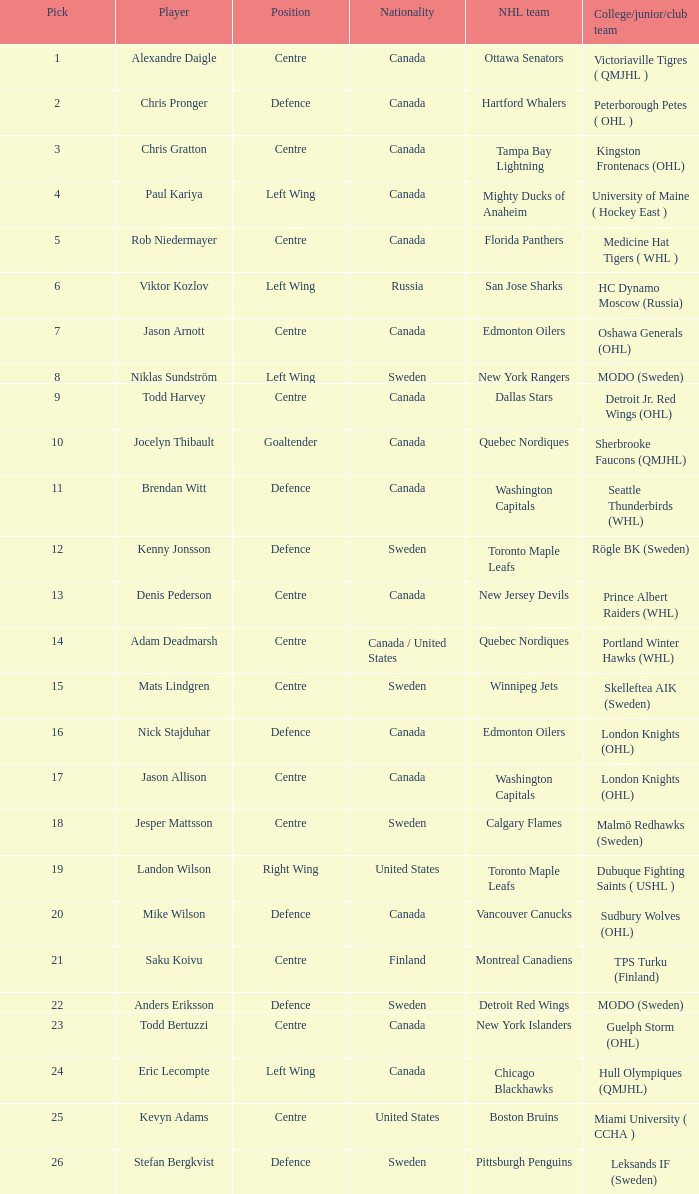Parse the table in full. {'header': ['Pick', 'Player', 'Position', 'Nationality', 'NHL team', 'College/junior/club team'], 'rows': [['1', 'Alexandre Daigle', 'Centre', 'Canada', 'Ottawa Senators', 'Victoriaville Tigres ( QMJHL )'], ['2', 'Chris Pronger', 'Defence', 'Canada', 'Hartford Whalers', 'Peterborough Petes ( OHL )'], ['3', 'Chris Gratton', 'Centre', 'Canada', 'Tampa Bay Lightning', 'Kingston Frontenacs (OHL)'], ['4', 'Paul Kariya', 'Left Wing', 'Canada', 'Mighty Ducks of Anaheim', 'University of Maine ( Hockey East )'], ['5', 'Rob Niedermayer', 'Centre', 'Canada', 'Florida Panthers', 'Medicine Hat Tigers ( WHL )'], ['6', 'Viktor Kozlov', 'Left Wing', 'Russia', 'San Jose Sharks', 'HC Dynamo Moscow (Russia)'], ['7', 'Jason Arnott', 'Centre', 'Canada', 'Edmonton Oilers', 'Oshawa Generals (OHL)'], ['8', 'Niklas Sundström', 'Left Wing', 'Sweden', 'New York Rangers', 'MODO (Sweden)'], ['9', 'Todd Harvey', 'Centre', 'Canada', 'Dallas Stars', 'Detroit Jr. Red Wings (OHL)'], ['10', 'Jocelyn Thibault', 'Goaltender', 'Canada', 'Quebec Nordiques', 'Sherbrooke Faucons (QMJHL)'], ['11', 'Brendan Witt', 'Defence', 'Canada', 'Washington Capitals', 'Seattle Thunderbirds (WHL)'], ['12', 'Kenny Jonsson', 'Defence', 'Sweden', 'Toronto Maple Leafs', 'Rögle BK (Sweden)'], ['13', 'Denis Pederson', 'Centre', 'Canada', 'New Jersey Devils', 'Prince Albert Raiders (WHL)'], ['14', 'Adam Deadmarsh', 'Centre', 'Canada / United States', 'Quebec Nordiques', 'Portland Winter Hawks (WHL)'], ['15', 'Mats Lindgren', 'Centre', 'Sweden', 'Winnipeg Jets', 'Skelleftea AIK (Sweden)'], ['16', 'Nick Stajduhar', 'Defence', 'Canada', 'Edmonton Oilers', 'London Knights (OHL)'], ['17', 'Jason Allison', 'Centre', 'Canada', 'Washington Capitals', 'London Knights (OHL)'], ['18', 'Jesper Mattsson', 'Centre', 'Sweden', 'Calgary Flames', 'Malmö Redhawks (Sweden)'], ['19', 'Landon Wilson', 'Right Wing', 'United States', 'Toronto Maple Leafs', 'Dubuque Fighting Saints ( USHL )'], ['20', 'Mike Wilson', 'Defence', 'Canada', 'Vancouver Canucks', 'Sudbury Wolves (OHL)'], ['21', 'Saku Koivu', 'Centre', 'Finland', 'Montreal Canadiens', 'TPS Turku (Finland)'], ['22', 'Anders Eriksson', 'Defence', 'Sweden', 'Detroit Red Wings', 'MODO (Sweden)'], ['23', 'Todd Bertuzzi', 'Centre', 'Canada', 'New York Islanders', 'Guelph Storm (OHL)'], ['24', 'Eric Lecompte', 'Left Wing', 'Canada', 'Chicago Blackhawks', 'Hull Olympiques (QMJHL)'], ['25', 'Kevyn Adams', 'Centre', 'United States', 'Boston Bruins', 'Miami University ( CCHA )'], ['26', 'Stefan Bergkvist', 'Defence', 'Sweden', 'Pittsburgh Penguins', 'Leksands IF (Sweden)']]} For how many nhl teams has denis pederson been a draft pick? 1.0. 